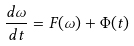<formula> <loc_0><loc_0><loc_500><loc_500>\frac { d \omega } { d t } = F ( \omega ) + \Phi ( t )</formula> 